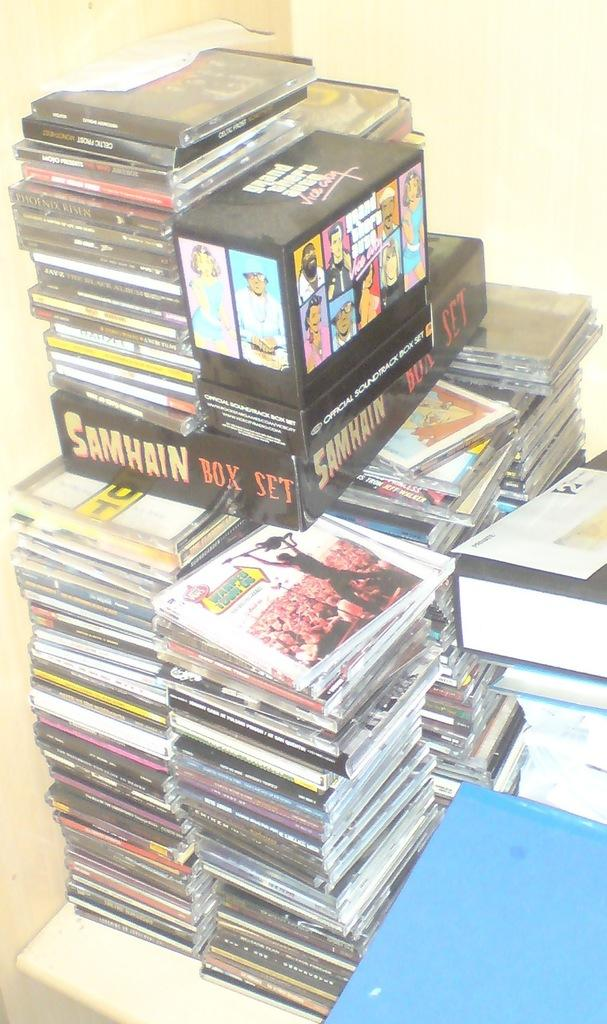<image>
Offer a succinct explanation of the picture presented. a group of games, one of which is grand theft auto Vice City 